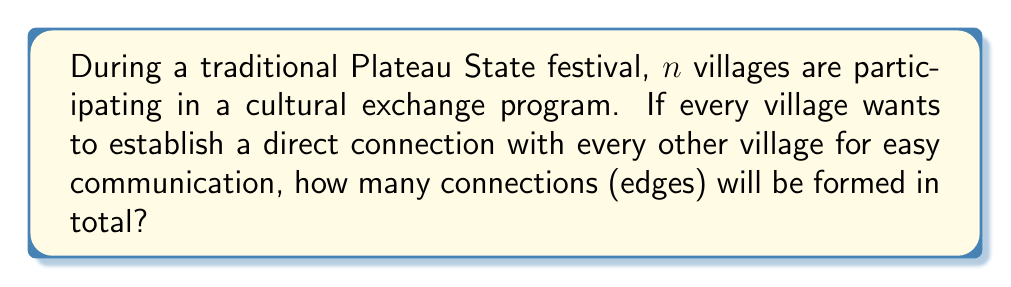Solve this math problem. To solve this problem, we need to understand that this scenario represents a complete graph, where each village is a vertex and each connection is an edge. In a complete graph, every vertex is connected to every other vertex.

Let's approach this step-by-step:

1) In a complete graph with $n$ vertices, each vertex is connected to $(n-1)$ other vertices.

2) This might lead us to think that the total number of edges is $n(n-1)$. However, this count is twice the actual number because each edge is counted twice (once from each end).

3) Therefore, we need to divide this by 2 to get the correct number of edges.

4) The formula for the number of edges in a complete graph with $n$ vertices is:

   $$E = \frac{n(n-1)}{2}$$

5) This formula can also be written as:

   $$E = \binom{n}{2}$$

   Which represents the number of ways to choose 2 vertices from $n$ vertices to form an edge.

6) The reasoning behind this formula is that for the first vertex, we have $n$ choices, and for the second vertex, we have $(n-1)$ choices. We divide by 2 because the order doesn't matter (edge AB is the same as edge BA).

Therefore, if we know the number of villages ($n$), we can easily calculate the total number of connections using this formula.
Answer: The number of edges (connections) in a complete graph with $n$ vertices (villages) is given by the formula:

$$E = \frac{n(n-1)}{2}$$ or $$E = \binom{n}{2}$$ 